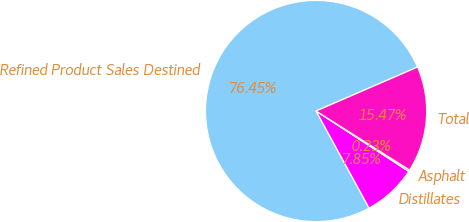Convert chart. <chart><loc_0><loc_0><loc_500><loc_500><pie_chart><fcel>Refined Product Sales Destined<fcel>Distillates<fcel>Asphalt<fcel>Total<nl><fcel>76.45%<fcel>7.85%<fcel>0.23%<fcel>15.47%<nl></chart> 